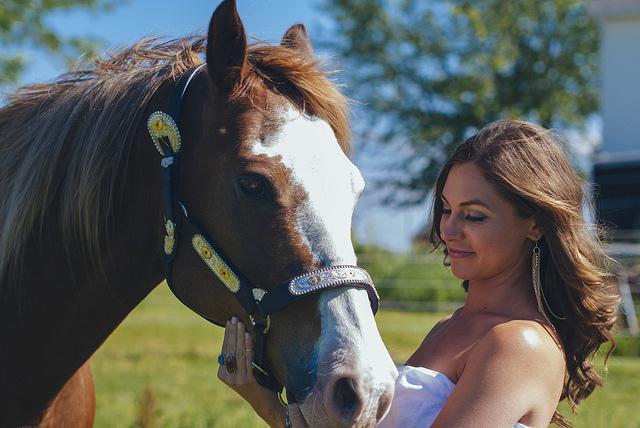How many animals?
Give a very brief answer. 1. How many people can you see?
Give a very brief answer. 1. 